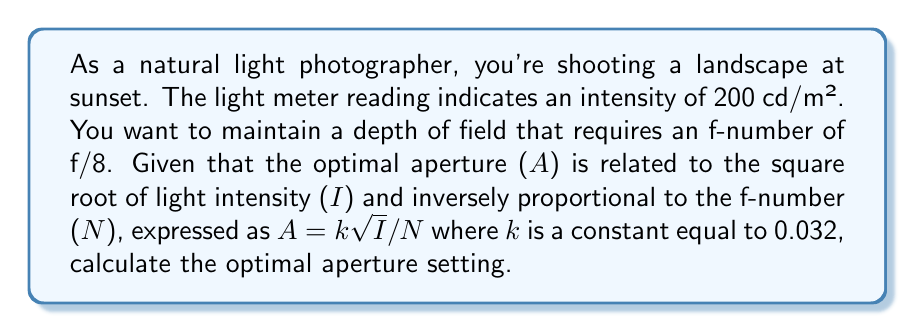What is the answer to this math problem? To solve this problem, we'll use the given equation and substitute the known values:

$$A = k\sqrt{I}/N$$

Where:
$A$ = Optimal aperture (unknown)
$k$ = Constant = 0.032
$I$ = Light intensity = 200 cd/m²
$N$ = f-number = 8

Step 1: Substitute the values into the equation
$$A = 0.032 \sqrt{200} / 8$$

Step 2: Simplify the square root
$$A = 0.032 \cdot 14.14 / 8$$

Step 3: Multiply the numerator
$$A = 0.45248 / 8$$

Step 4: Divide to get the final result
$$A = 0.0566$$

The optimal aperture setting is approximately 0.0566.
Answer: $0.0566$ 